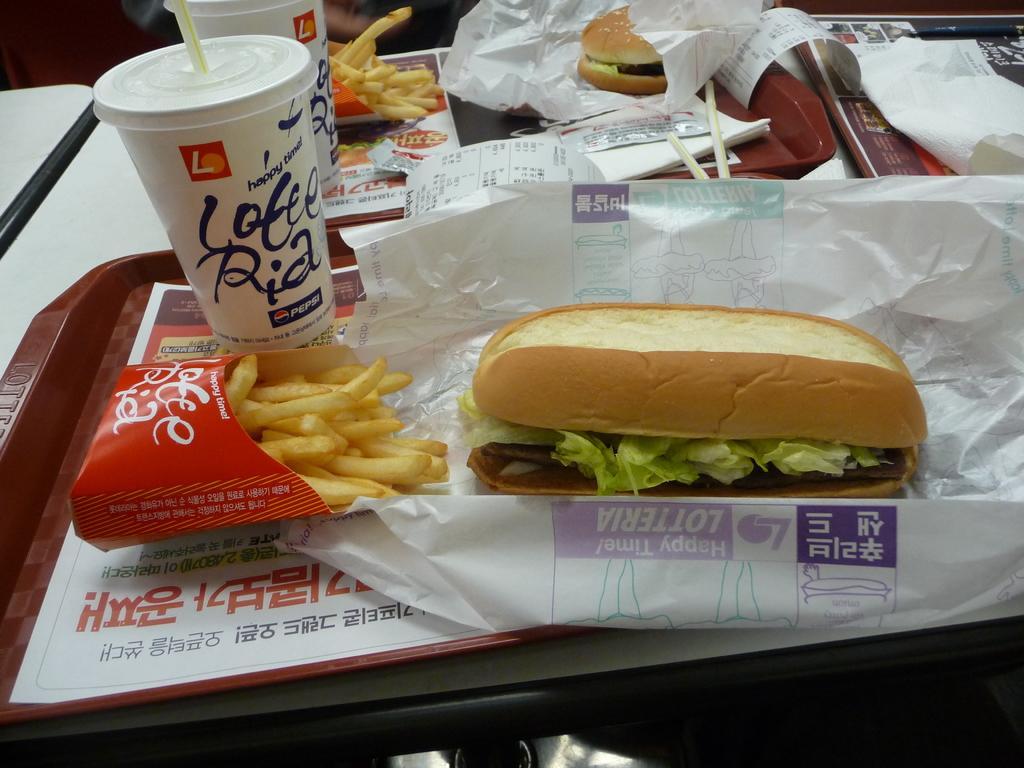Could you give a brief overview of what you see in this image? In the image in the center we can see one table. On table,we can see plates,tissue papers,cool drink glasses,hot dogs,sauce packets,bill paper,french fries and few other objects. 